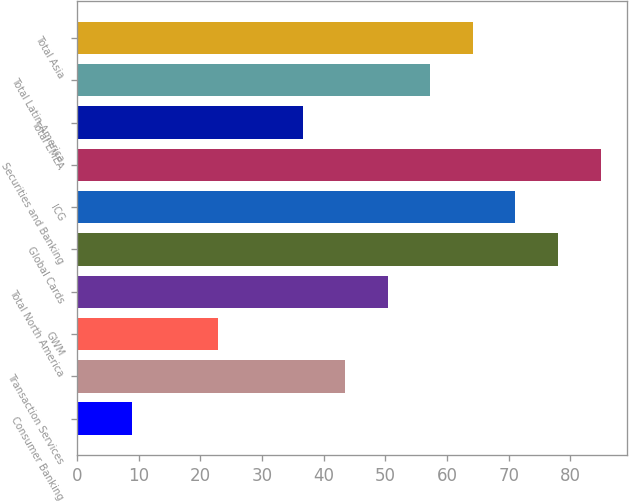Convert chart. <chart><loc_0><loc_0><loc_500><loc_500><bar_chart><fcel>Consumer Banking<fcel>Transaction Services<fcel>GWM<fcel>Total North America<fcel>Global Cards<fcel>ICG<fcel>Securities and Banking<fcel>Total EMEA<fcel>Total Latin America<fcel>Total Asia<nl><fcel>9<fcel>43.5<fcel>22.8<fcel>50.4<fcel>78<fcel>71.1<fcel>84.9<fcel>36.6<fcel>57.3<fcel>64.2<nl></chart> 